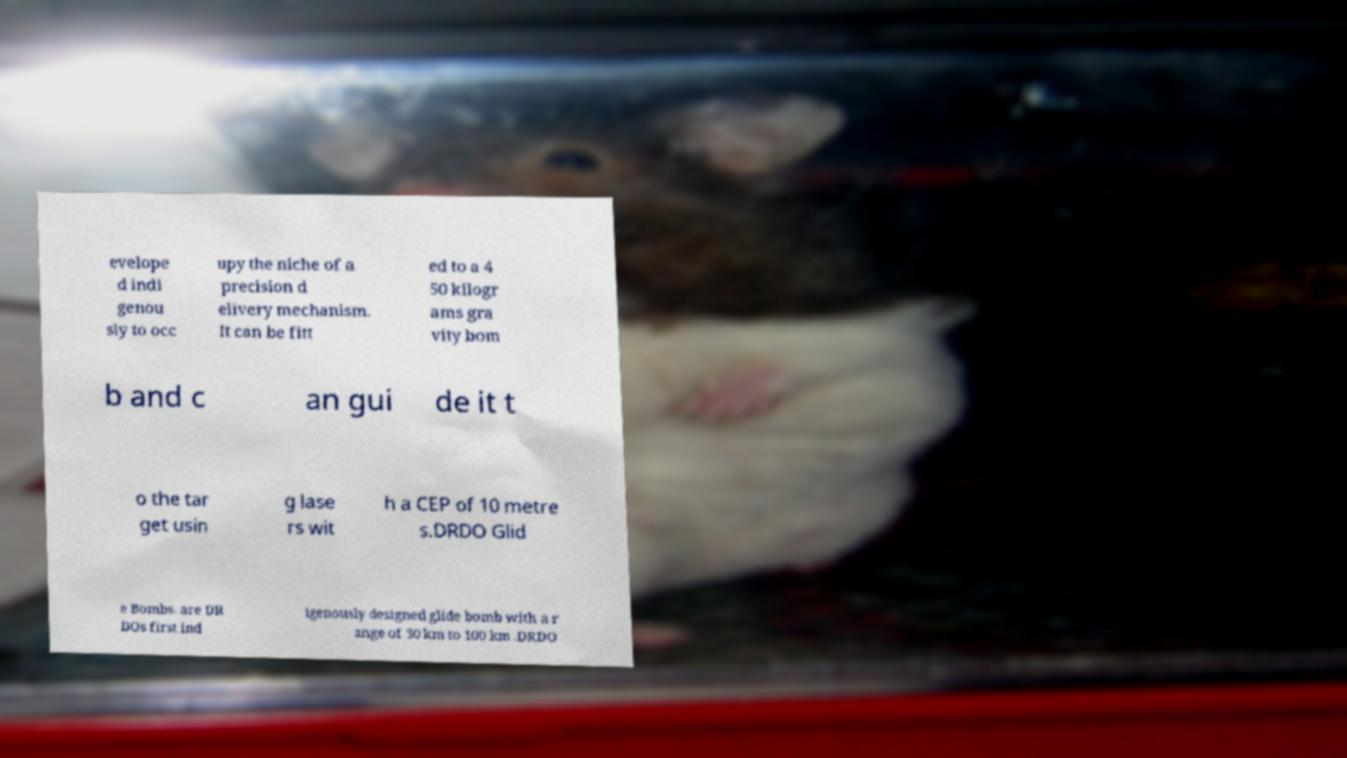There's text embedded in this image that I need extracted. Can you transcribe it verbatim? evelope d indi genou sly to occ upy the niche of a precision d elivery mechanism. It can be fitt ed to a 4 50 kilogr ams gra vity bom b and c an gui de it t o the tar get usin g lase rs wit h a CEP of 10 metre s.DRDO Glid e Bombs. are DR DOs first ind igenously designed glide bomb with a r ange of 30 km to 100 km .DRDO 